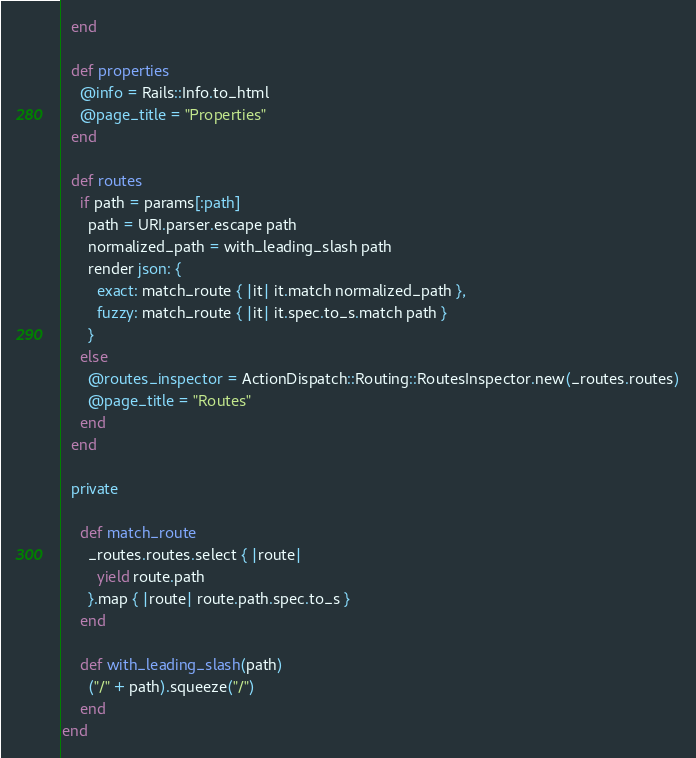<code> <loc_0><loc_0><loc_500><loc_500><_Ruby_>  end

  def properties
    @info = Rails::Info.to_html
    @page_title = "Properties"
  end

  def routes
    if path = params[:path]
      path = URI.parser.escape path
      normalized_path = with_leading_slash path
      render json: {
        exact: match_route { |it| it.match normalized_path },
        fuzzy: match_route { |it| it.spec.to_s.match path }
      }
    else
      @routes_inspector = ActionDispatch::Routing::RoutesInspector.new(_routes.routes)
      @page_title = "Routes"
    end
  end

  private

    def match_route
      _routes.routes.select { |route|
        yield route.path
      }.map { |route| route.path.spec.to_s }
    end

    def with_leading_slash(path)
      ("/" + path).squeeze("/")
    end
end
</code> 